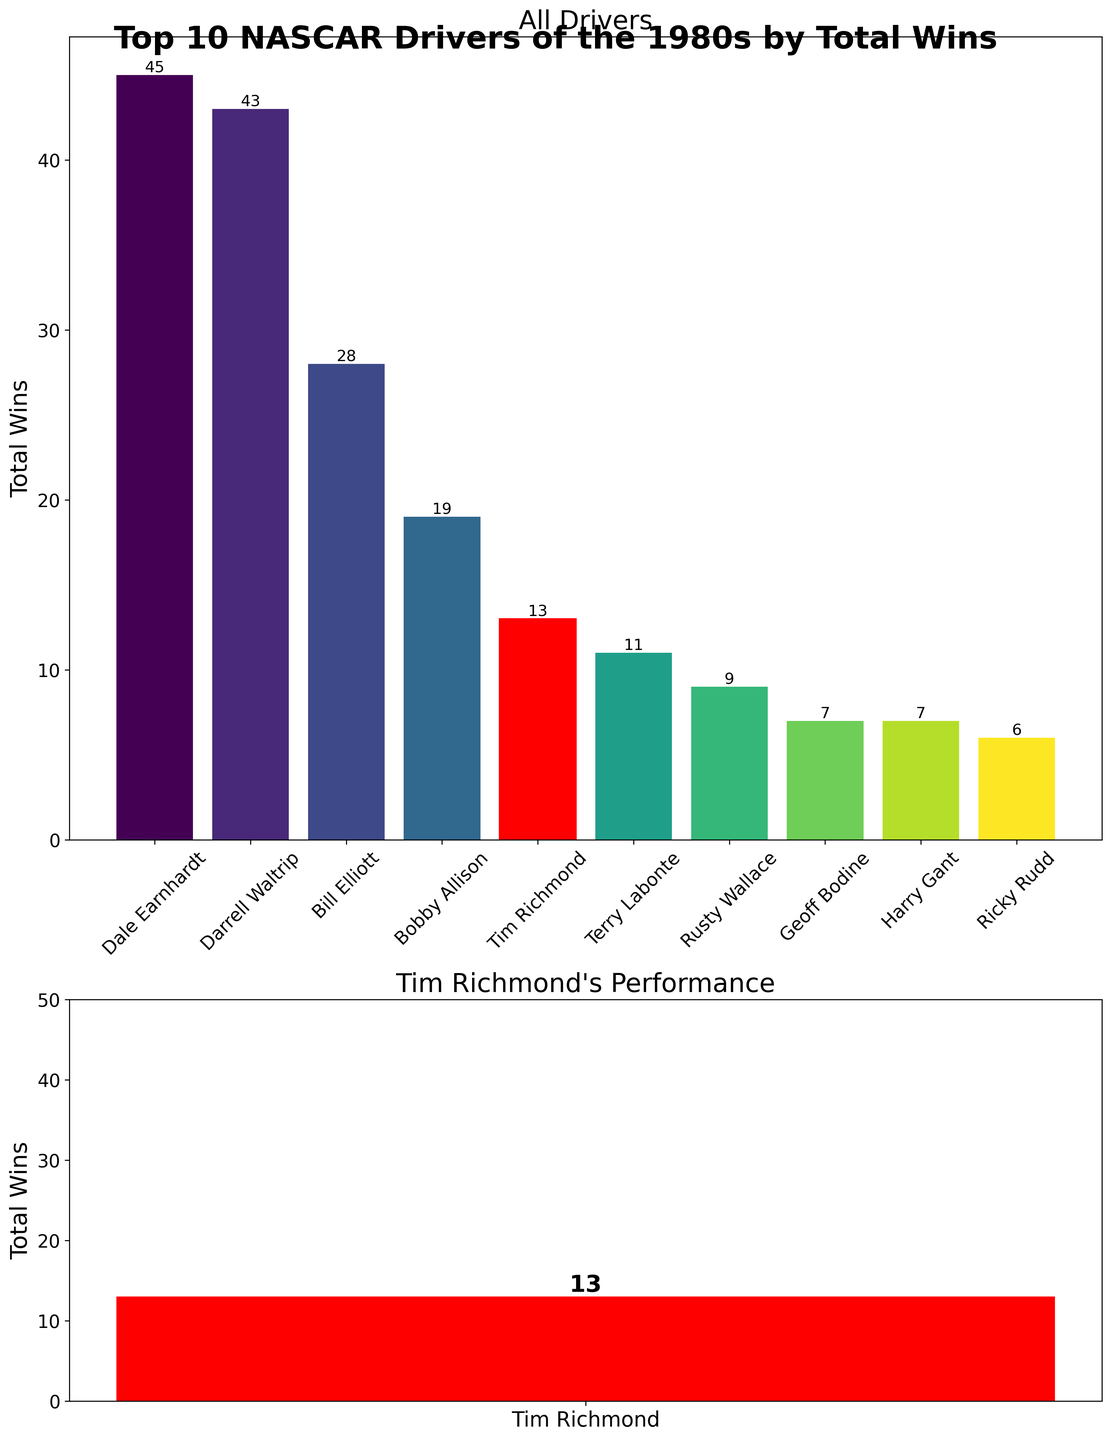What's the total number of wins for all drivers combined in the 1980s? Sum up the wins for all drivers: 45 (Dale Earnhardt) + 43 (Darrell Waltrip) + 28 (Bill Elliott) + 19 (Bobby Allison) + 13 (Tim Richmond) + 11 (Terry Labonte) + 9 (Rusty Wallace) + 7 (Geoff Bodine) + 7 (Harry Gant) + 6 (Ricky Rudd) = 188
Answer: 188 How many more wins does Dale Earnhardt have compared to Tim Richmond? Dale Earnhardt has 45 wins, and Tim Richmond has 13 wins. Subtract Richmond's wins from Earnhardt's: 45 - 13 = 32
Answer: 32 Who has more wins, Bill Elliott or Tim Richmond, and by how many? Bill Elliott has 28 wins, and Tim Richmond has 13 wins. Calculate the difference: 28 - 13 = 15
Answer: Bill Elliott by 15 Which driver has the lowest total wins, and how many wins do they have? Ricky Rudd has the lowest number of wins with 6. This can be identified by looking at the height of the bars where his bar is the shortest
Answer: Ricky Rudd with 6 What is the average number of wins across all drivers? Sum up the wins, then divide by the number of drivers: (45 + 43 + 28 + 19 + 13 + 11 + 9 + 7 + 7 + 6) / 10 = 188 / 10 = 18.8
Answer: 18.8 What's the range of the wins among the top 10 drivers? The range is the difference between the highest and lowest values: 45 (highest) - 6 (lowest) = 39
Answer: 39 Which drivers have wins between (and including) 10 and 20? The wins in this interval are 19 (Bobby Allison) and 11 (Terry Labonte). So, the drivers are Bobby Allison and Terry Labonte
Answer: Bobby Allison and Terry Labonte How many wins does the tallest bar represent, and which driver is it? The tallest bar represents 45 wins, and the driver is Dale Earnhardt
Answer: 45, Dale Earnhardt What color is Tim Richmond's bar in the top subplot, and why is it different? Tim Richmond's bar is red to highlight his performance compared to other drivers, whose bars are in shades of another color
Answer: Red, highlighted Considering only Tim Richmond's performance, how many additional wins would he need to surpass Bobby Allison? Bobby Allison has 19 wins, and Tim Richmond has 13. He would need 19 - 13 = 6 more wins to surpass Allison
Answer: 6 